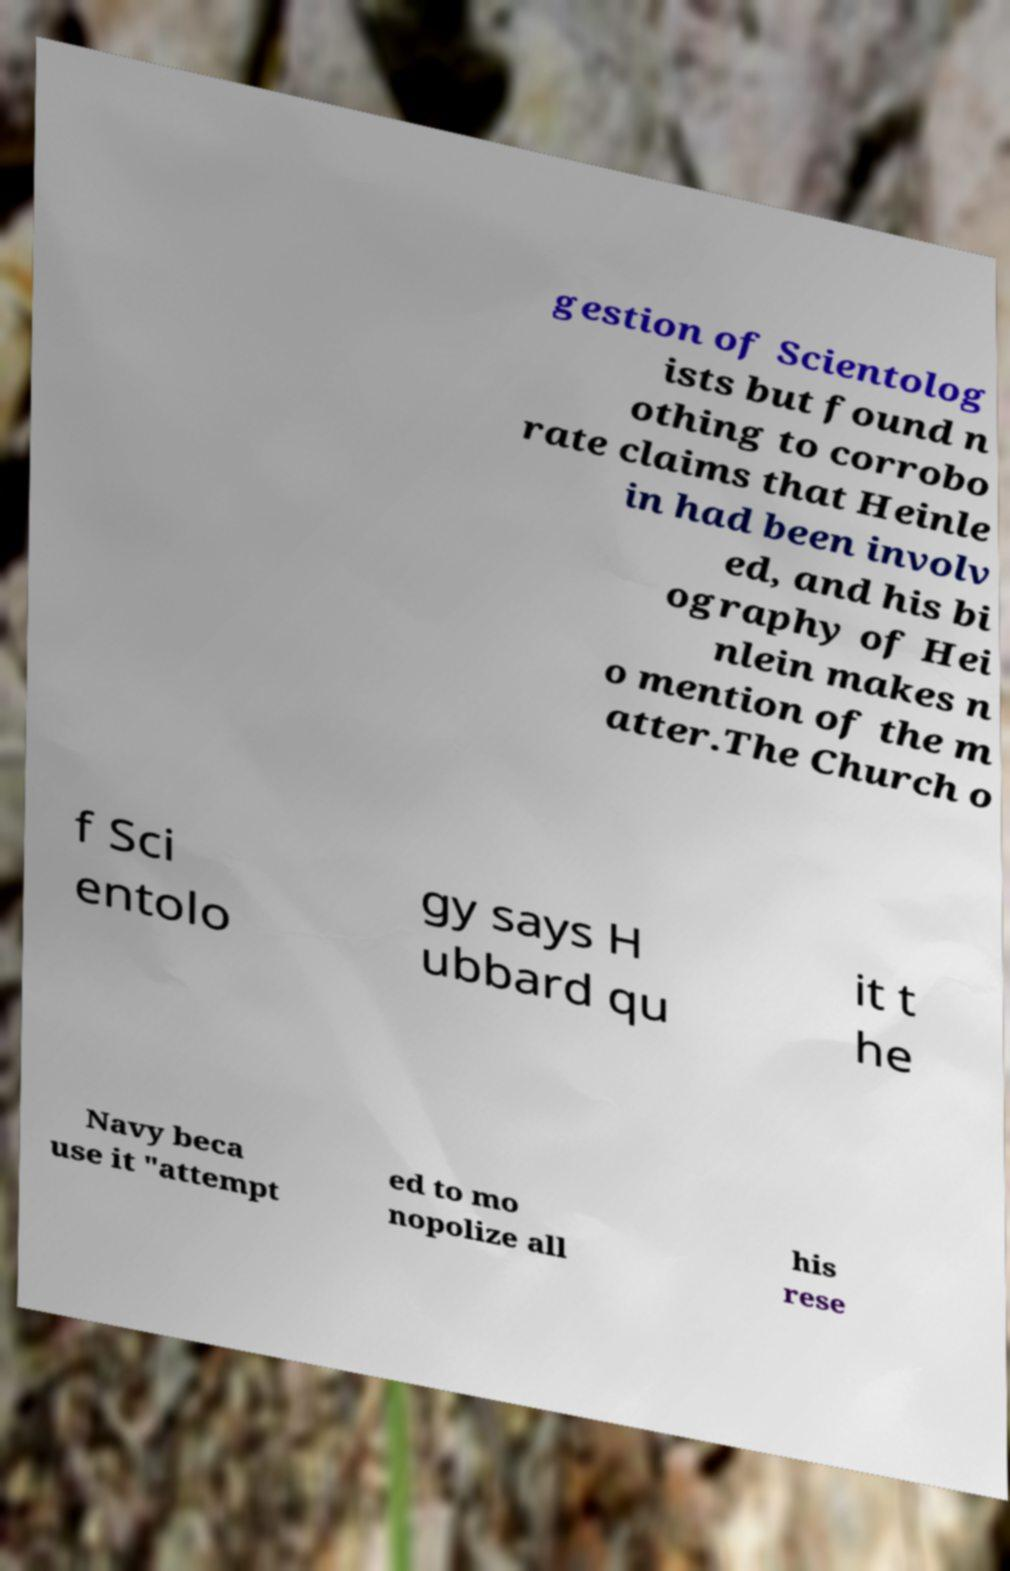Could you extract and type out the text from this image? gestion of Scientolog ists but found n othing to corrobo rate claims that Heinle in had been involv ed, and his bi ography of Hei nlein makes n o mention of the m atter.The Church o f Sci entolo gy says H ubbard qu it t he Navy beca use it "attempt ed to mo nopolize all his rese 